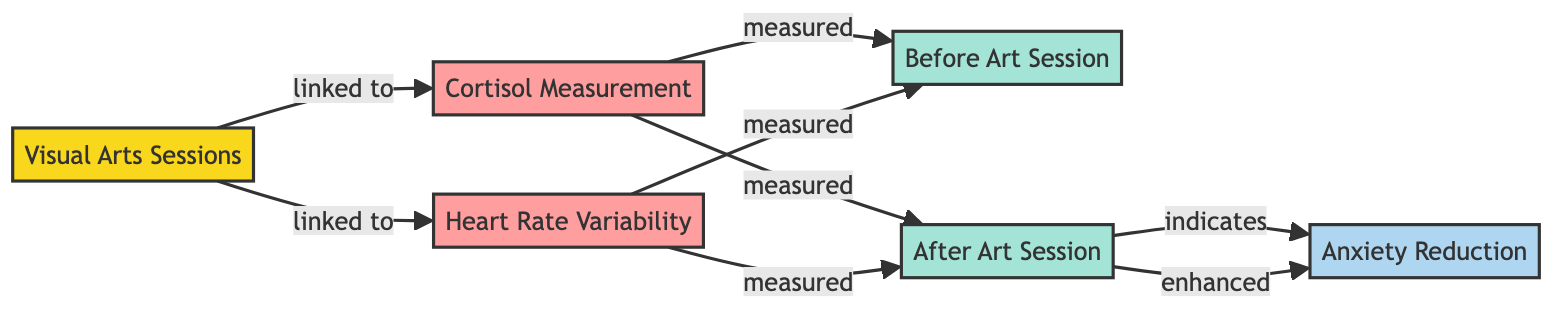What is the first activity listed in the diagram? The first activity node is labeled "Visual Arts Sessions," which is illustrated at the top of the diagram.
Answer: Visual Arts Sessions How many measurement nodes are present? There are two measurement nodes shown: "Cortisol Measurement" and "Heart Rate Variability," making a total of two measurement nodes.
Answer: 2 What does the "After Art Session" state indicate? The "After Art Session" node has connections to both cortisol measurement and heart rate variability measurements, indicating a state after engaging in the visual arts sessions.
Answer: Indicates a state after engaging in visual arts Which outcome is linked to the "After Art Session"? The outcome linked to the "After Art Session" is "Anxiety Reduction," which shows that the art session is intended to lead to a decrease in anxiety levels.
Answer: Anxiety Reduction What is the relationship between "Visual Arts Sessions" and "Heart Rate Variability"? The relationship illustrated is that "Visual Arts Sessions" are directly linked to "Heart Rate Variability," implying that engaging in visual arts affects heart rate measurements.
Answer: Linked to Which state is measured before the art session? The node labeled "Before Art Session" is explicitly defined as the state measured prior to engaging in the visual arts sessions.
Answer: Before Art Session What does the "Cortisol Measurement" node measure? The "Cortisol Measurement" node measures cortisol levels at two points in time: before and after the art session, directly assessing the physiological response associated with anxiety.
Answer: Cortisol levels Explain how anxiety reduction is achieved after the art session. Anxiety reduction is achieved through the measurement of cortisol levels and heart rate variability after the art session, demonstrating that engaging in visual arts can lead to physiological changes associated with stress reduction, indicated by higher heart rate variability and lower cortisol levels.
Answer: Higher heart rate variability and lower cortisol levels indicate anxiety reduction Which two measurements are taken before the art session? The two measurements taken before the art session are cortisol levels (Cortisol Measurement) and heart rate variability (Heart Rate Variability), both measured at the same node labeled "Before Art Session."
Answer: Cortisol and Heart Rate Variability 